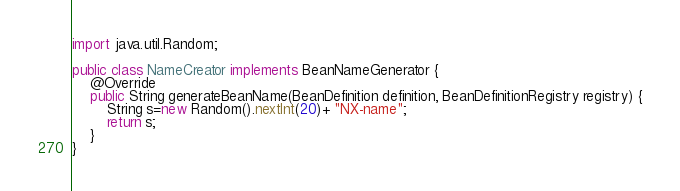Convert code to text. <code><loc_0><loc_0><loc_500><loc_500><_Java_>
import java.util.Random;

public class NameCreator implements BeanNameGenerator {
	@Override
	public String generateBeanName(BeanDefinition definition, BeanDefinitionRegistry registry) {
		String s=new Random().nextInt(20)+ "NX-name";
		return s;
	}
}
</code> 